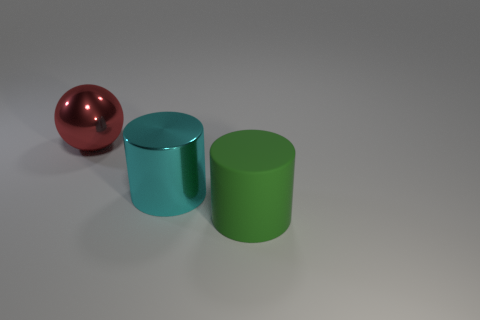Add 1 blue shiny balls. How many objects exist? 4 Subtract all green cylinders. How many cylinders are left? 1 Subtract all cylinders. How many objects are left? 1 Subtract 1 cylinders. How many cylinders are left? 1 Subtract all gray balls. Subtract all blue cubes. How many balls are left? 1 Subtract all cyan cubes. How many cyan cylinders are left? 1 Subtract all rubber cubes. Subtract all large cylinders. How many objects are left? 1 Add 1 matte objects. How many matte objects are left? 2 Add 1 tiny red metallic balls. How many tiny red metallic balls exist? 1 Subtract 0 purple cylinders. How many objects are left? 3 